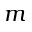<formula> <loc_0><loc_0><loc_500><loc_500>m</formula> 